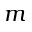<formula> <loc_0><loc_0><loc_500><loc_500>m</formula> 